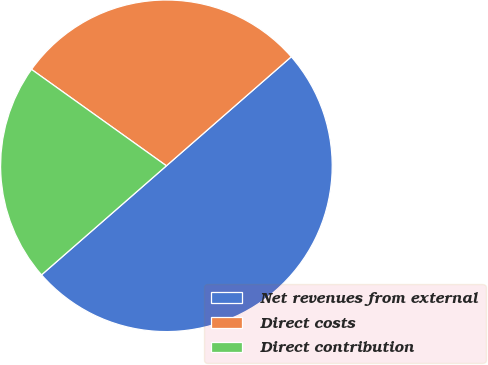<chart> <loc_0><loc_0><loc_500><loc_500><pie_chart><fcel>Net revenues from external<fcel>Direct costs<fcel>Direct contribution<nl><fcel>50.0%<fcel>28.7%<fcel>21.3%<nl></chart> 